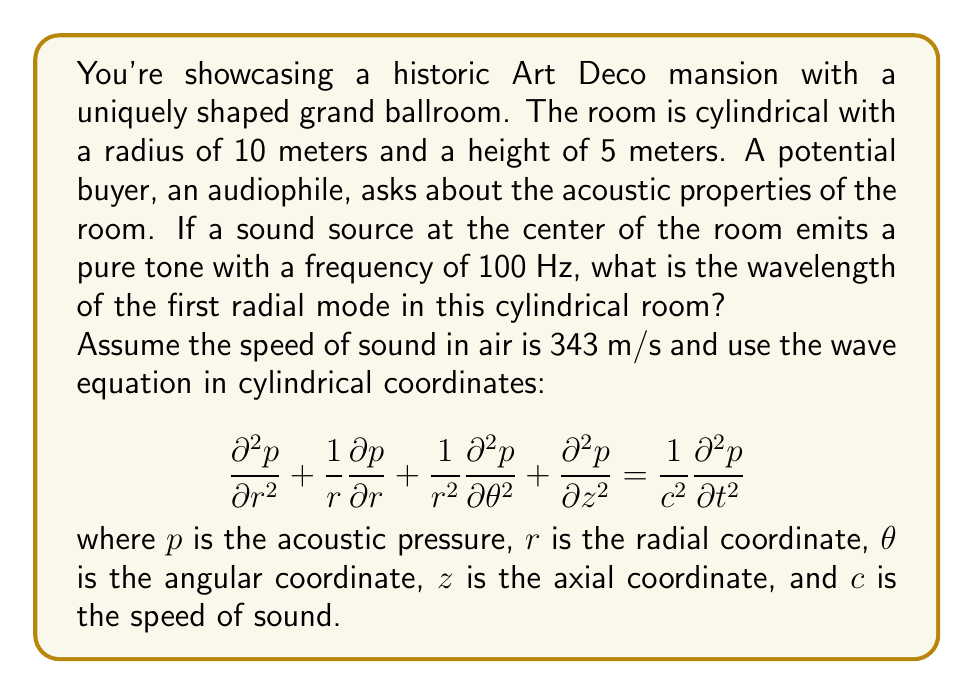Help me with this question. To solve this problem, we need to consider the wave equation in cylindrical coordinates and focus on the radial component. The solution for the radial mode can be expressed using Bessel functions.

1) For a cylindrical room, the radial component of the solution takes the form:

   $$p(r,t) = J_0(k_r r) e^{i\omega t}$$

   where $J_0$ is the Bessel function of the first kind of order 0, $k_r$ is the radial wavenumber, and $\omega$ is the angular frequency.

2) The boundary condition for a hard wall is that the radial velocity is zero at the wall:

   $$\frac{\partial p}{\partial r} = 0 \quad \text{at} \quad r = R$$

   where $R$ is the radius of the room (10 m in this case).

3) This condition is satisfied when:

   $$J_1(k_r R) = 0$$

   where $J_1$ is the Bessel function of the first kind of order 1.

4) The first zero of $J_1$ occurs at $k_r R \approx 3.8317$.

5) Therefore, for the first radial mode:

   $$k_r = \frac{3.8317}{R} = \frac{3.8317}{10} \approx 0.38317 \text{ m}^{-1}$$

6) The wavelength $\lambda$ is related to $k_r$ by:

   $$\lambda = \frac{2\pi}{k_r}$$

7) Substituting the value of $k_r$:

   $$\lambda = \frac{2\pi}{0.38317} \approx 16.40 \text{ m}$$

This wavelength corresponds to the first radial mode of the room, regardless of the frequency of the sound source. The frequency given (100 Hz) is not directly used in this calculation but could be used to determine if this mode would be excited in practice.
Answer: The wavelength of the first radial mode in the cylindrical room is approximately 16.40 meters. 